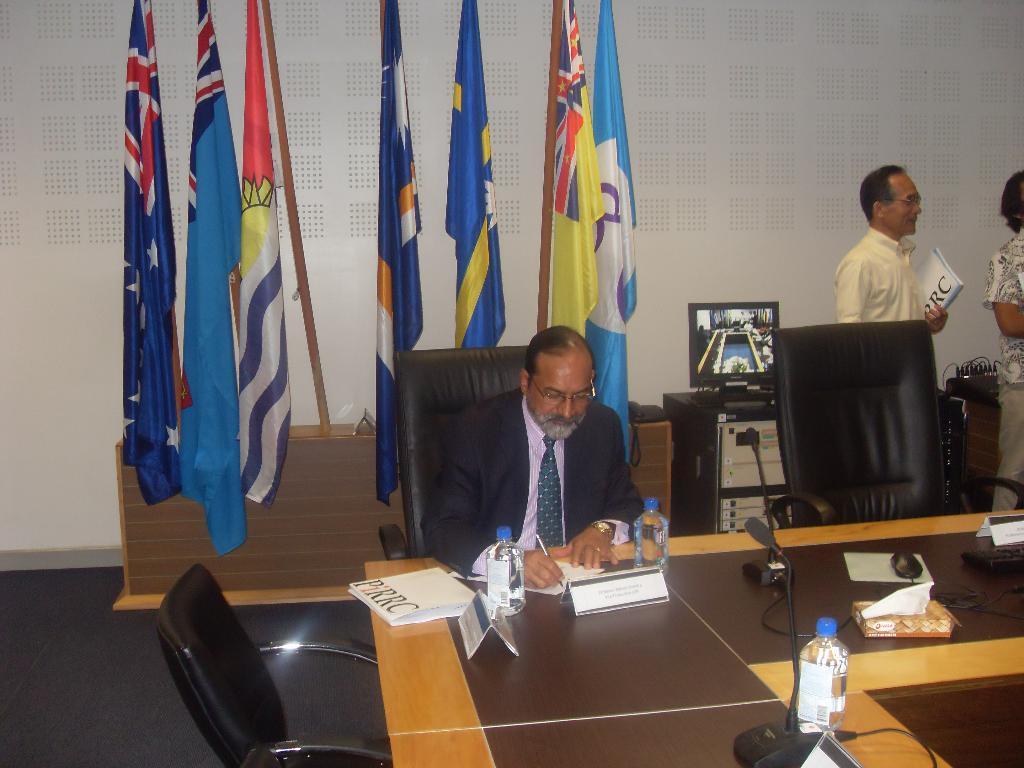In one or two sentences, can you explain what this image depicts? There is a man sitting on the chair, holding pen and writing something on the paper. Next to him we can see two water bottles on the table. And there is a microphone on the table. In the background we can see a wall and these are the flags and we can also see a computer. And Beside computer we can see a man holding a book and next to him we can see a woman. 